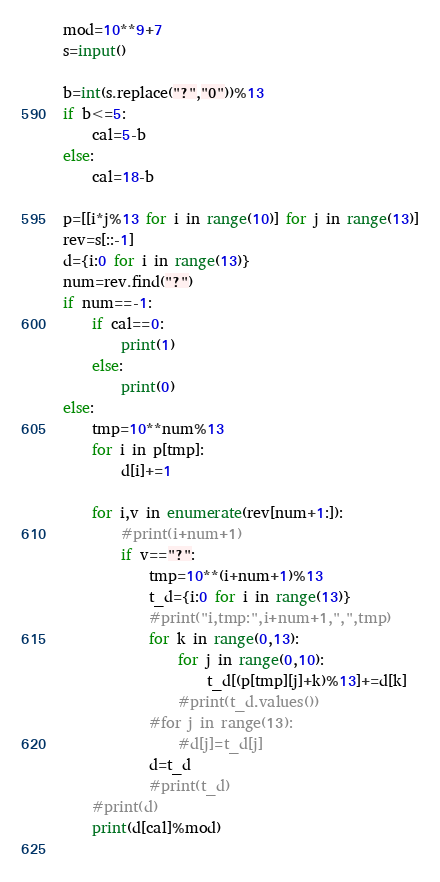Convert code to text. <code><loc_0><loc_0><loc_500><loc_500><_Python_>mod=10**9+7
s=input()

b=int(s.replace("?","0"))%13
if b<=5:
    cal=5-b
else:
    cal=18-b

p=[[i*j%13 for i in range(10)] for j in range(13)]
rev=s[::-1]
d={i:0 for i in range(13)}
num=rev.find("?")
if num==-1:
    if cal==0:
        print(1)
    else:
        print(0)
else:
    tmp=10**num%13
    for i in p[tmp]:
        d[i]+=1

    for i,v in enumerate(rev[num+1:]):
        #print(i+num+1)
        if v=="?":
            tmp=10**(i+num+1)%13
            t_d={i:0 for i in range(13)}
            #print("i,tmp:",i+num+1,",",tmp)
            for k in range(0,13):
                for j in range(0,10):
                    t_d[(p[tmp][j]+k)%13]+=d[k]
                #print(t_d.values())
            #for j in range(13):
                #d[j]=t_d[j]
            d=t_d
            #print(t_d)
    #print(d)
    print(d[cal]%mod)
        

</code> 